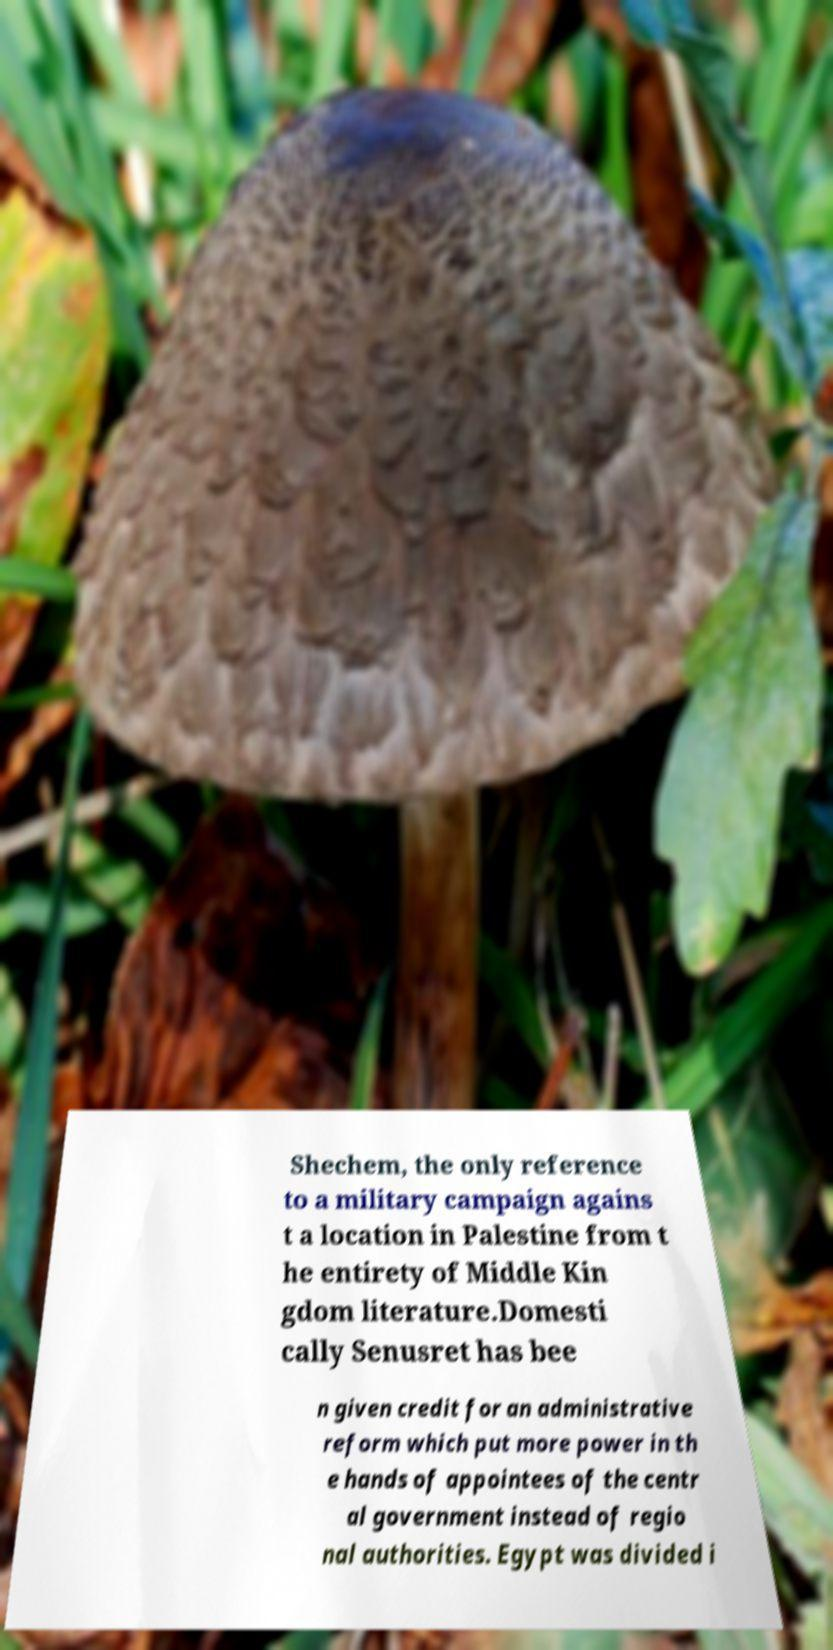For documentation purposes, I need the text within this image transcribed. Could you provide that? Shechem, the only reference to a military campaign agains t a location in Palestine from t he entirety of Middle Kin gdom literature.Domesti cally Senusret has bee n given credit for an administrative reform which put more power in th e hands of appointees of the centr al government instead of regio nal authorities. Egypt was divided i 